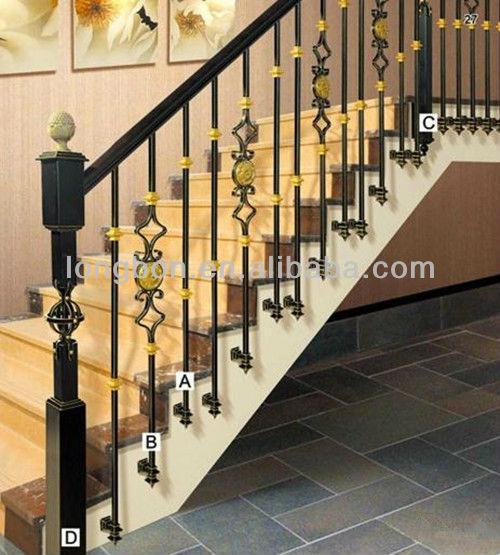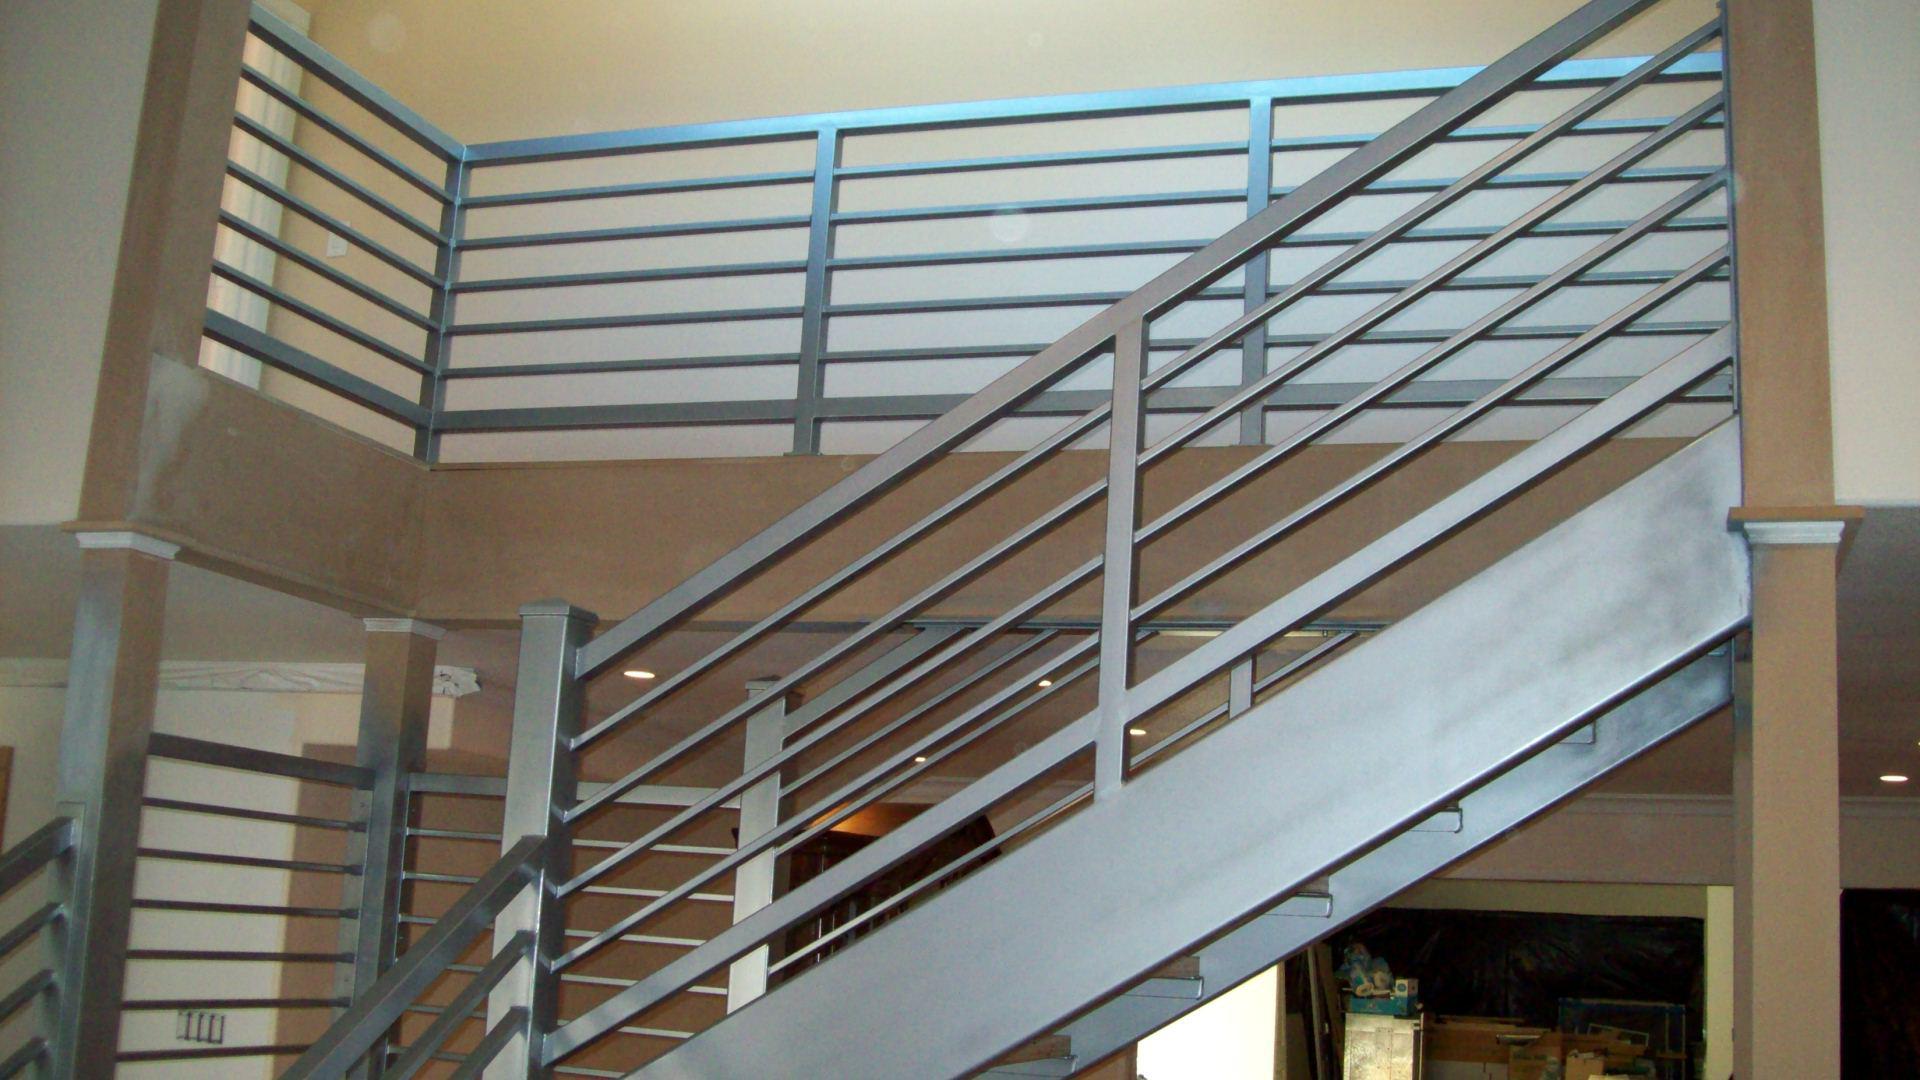The first image is the image on the left, the second image is the image on the right. Given the left and right images, does the statement "There is at least one staircase with horizontal railings." hold true? Answer yes or no. Yes. 